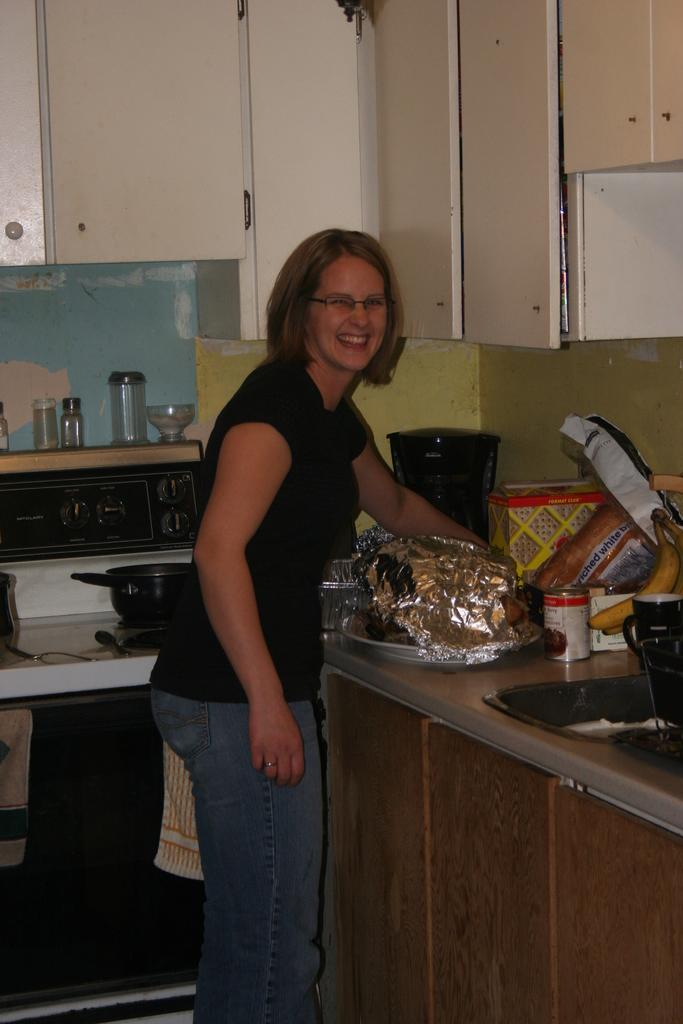<image>
Provide a brief description of the given image. a woman standing in front of a counter with an enriched white bread loaf on it 